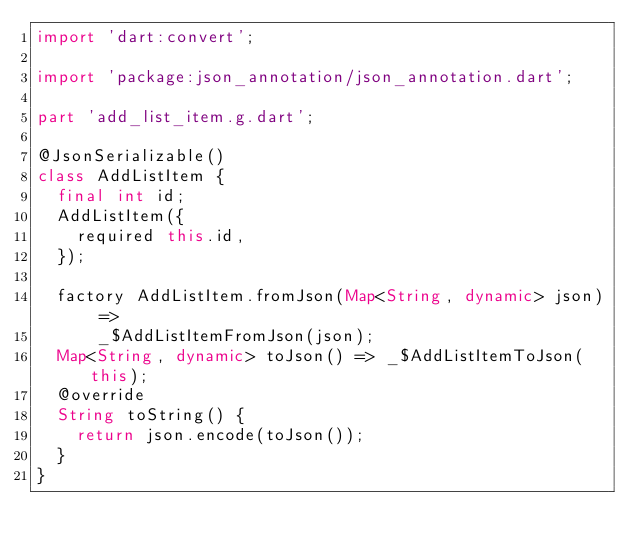Convert code to text. <code><loc_0><loc_0><loc_500><loc_500><_Dart_>import 'dart:convert';

import 'package:json_annotation/json_annotation.dart';

part 'add_list_item.g.dart';

@JsonSerializable()
class AddListItem {
  final int id;
  AddListItem({
    required this.id,
  });

  factory AddListItem.fromJson(Map<String, dynamic> json) =>
      _$AddListItemFromJson(json);
  Map<String, dynamic> toJson() => _$AddListItemToJson(this);
  @override
  String toString() {
    return json.encode(toJson());
  }
}
</code> 